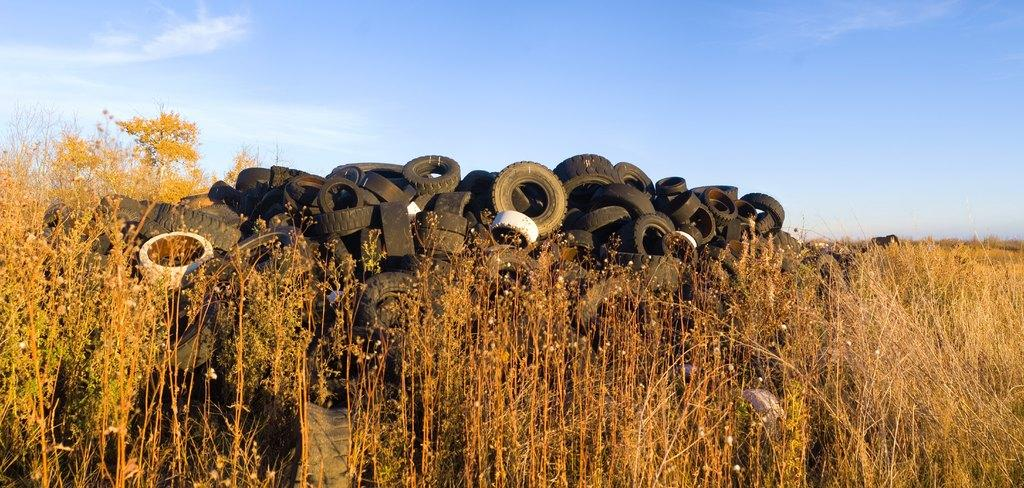What is the main subject of the image? The main subject of the image is many tyres. Where are the tyres located? The tyres are on the surface of the grass. What can be seen in the background of the image? There is a sky visible in the background of the image. What type of match is being played in the image? There is no match being played in the image; it features many tyres on the grass. What is the secretary doing in the image? There is no secretary present in the image. 